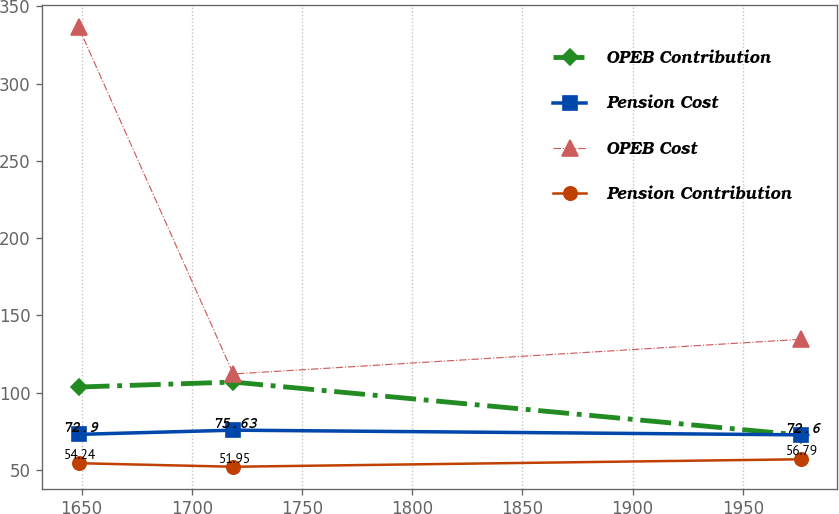Convert chart to OTSL. <chart><loc_0><loc_0><loc_500><loc_500><line_chart><ecel><fcel>OPEB Contribution<fcel>Pension Cost<fcel>OPEB Cost<fcel>Pension Contribution<nl><fcel>1648.64<fcel>103.55<fcel>72.9<fcel>336.51<fcel>54.24<nl><fcel>1718.88<fcel>106.75<fcel>75.63<fcel>112<fcel>51.95<nl><fcel>1976.28<fcel>72.47<fcel>72.6<fcel>134.45<fcel>56.79<nl></chart> 